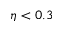Convert formula to latex. <formula><loc_0><loc_0><loc_500><loc_500>\eta < 0 . 3</formula> 